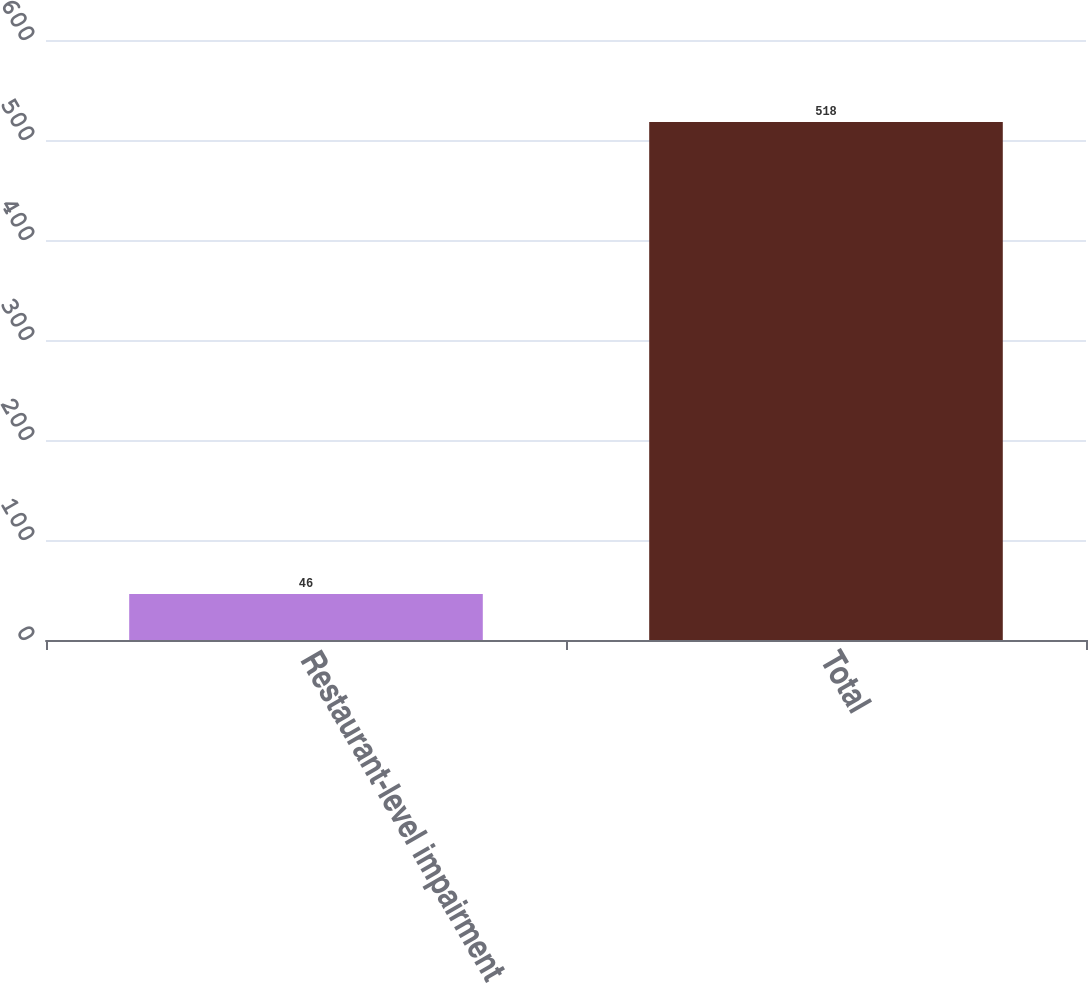Convert chart to OTSL. <chart><loc_0><loc_0><loc_500><loc_500><bar_chart><fcel>Restaurant-level impairment<fcel>Total<nl><fcel>46<fcel>518<nl></chart> 